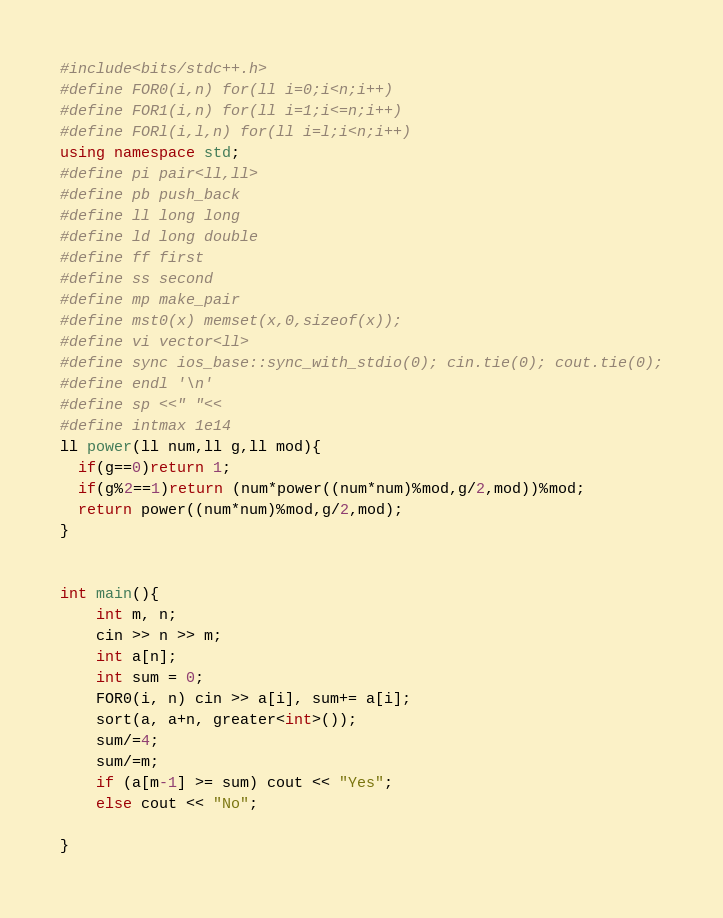Convert code to text. <code><loc_0><loc_0><loc_500><loc_500><_C++_>#include<bits/stdc++.h>
#define FOR0(i,n) for(ll i=0;i<n;i++)
#define FOR1(i,n) for(ll i=1;i<=n;i++)
#define FORl(i,l,n) for(ll i=l;i<n;i++)
using namespace std;
#define pi pair<ll,ll>
#define pb push_back
#define ll long long
#define ld long double
#define ff first
#define ss second
#define mp make_pair
#define mst0(x) memset(x,0,sizeof(x));
#define vi vector<ll>
#define sync ios_base::sync_with_stdio(0); cin.tie(0); cout.tie(0);
#define endl '\n'
#define sp <<" "<<
#define intmax 1e14
ll power(ll num,ll g,ll mod){
  if(g==0)return 1;
  if(g%2==1)return (num*power((num*num)%mod,g/2,mod))%mod;
  return power((num*num)%mod,g/2,mod);
}


int main(){
	int m, n;
	cin >> n >> m;
	int a[n];
	int sum = 0;
	FOR0(i, n) cin >> a[i], sum+= a[i];
	sort(a, a+n, greater<int>());
	sum/=4;
	sum/=m;
	if (a[m-1] >= sum) cout << "Yes";
	else cout << "No";

}</code> 